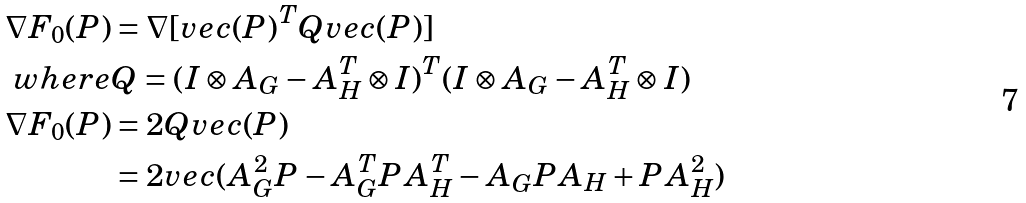<formula> <loc_0><loc_0><loc_500><loc_500>\nabla F _ { 0 } ( P ) & = \nabla [ v e c ( P ) ^ { T } Q v e c ( P ) ] \\ w h e r e & Q = ( I \otimes A _ { G } - A _ { H } ^ { T } \otimes I ) ^ { T } ( I \otimes A _ { G } - A _ { H } ^ { T } \otimes I ) \\ \nabla F _ { 0 } ( P ) & = 2 Q v e c ( P ) \\ & = 2 v e c ( A _ { G } ^ { 2 } P - A ^ { T } _ { G } P A ^ { T } _ { H } - A _ { G } P A _ { H } + P A _ { H } ^ { 2 } )</formula> 